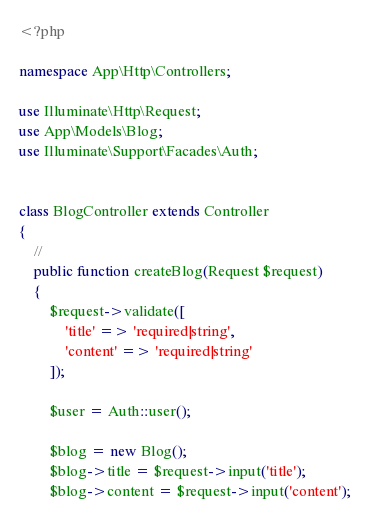<code> <loc_0><loc_0><loc_500><loc_500><_PHP_><?php

namespace App\Http\Controllers;

use Illuminate\Http\Request;
use App\Models\Blog;
use Illuminate\Support\Facades\Auth;


class BlogController extends Controller
{
    //
    public function createBlog(Request $request)
    {
        $request->validate([
            'title' => 'required|string',
            'content' => 'required|string'
        ]);

        $user = Auth::user();

        $blog = new Blog();
        $blog->title = $request->input('title');
        $blog->content = $request->input('content');</code> 